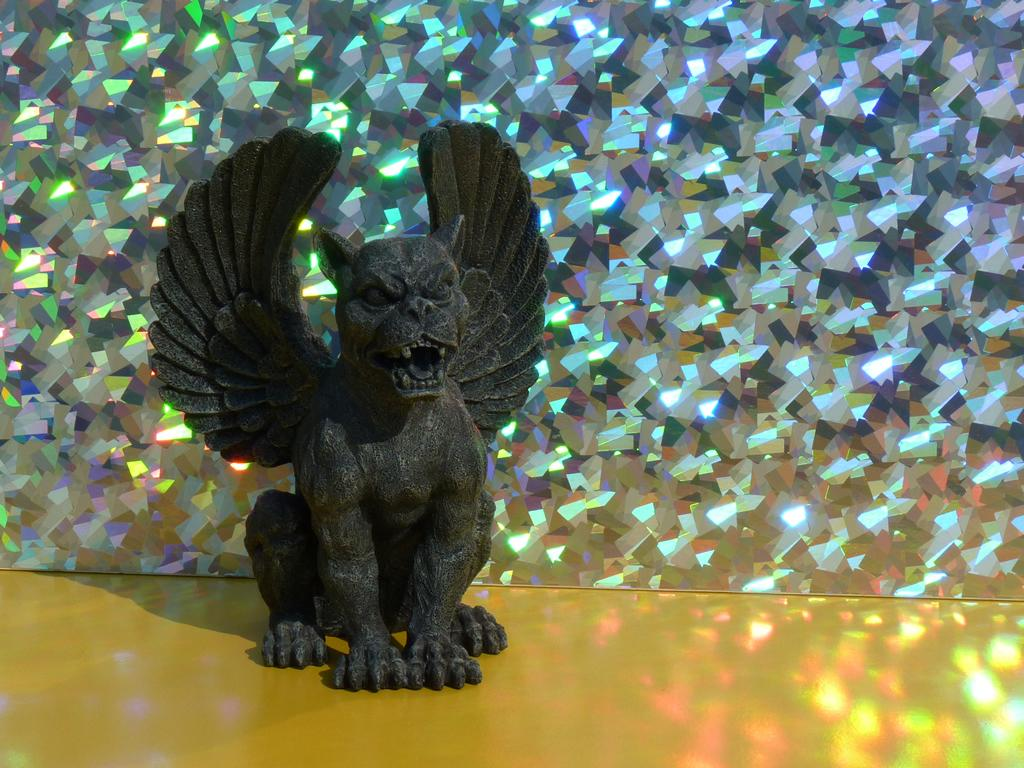What is the main subject in the front of the image? There is a statue in the front of the image. What is the color of the statue? The statue is black in color. What can be seen in the background of the image? There is an object in the background of the image. How would you describe the appearance of the object in the background? The object in the background is shining. What type of tooth is visible in the image? There is no tooth present in the image. Is the faucet turned on in the image? There is no faucet present in the image. 